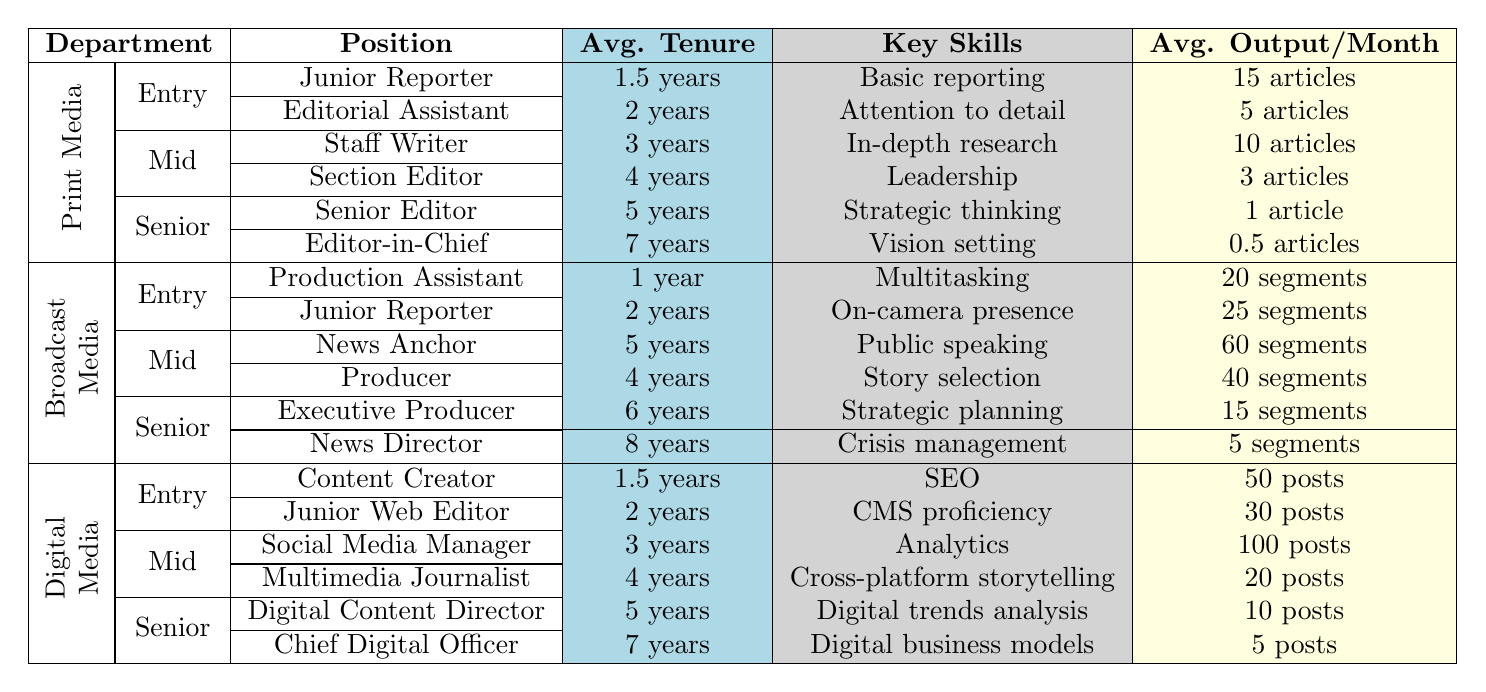What is the average tenure for a Junior Reporter in Print Media? The table shows that the average tenure for a Junior Reporter in Print Media is listed as 1.5 years.
Answer: 1.5 years Which role has the highest average output per month in Digital Media? The role of Social Media Manager has the highest average output per month with 100 posts, as compared to other roles in Digital Media.
Answer: Social Media Manager What is the typical assignment for a Senior Editor in Print Media? The typical assignment for a Senior Editor in Print Media is "Overall content strategy, mentoring," as indicated in the table under the Senior Level section for Print Media.
Answer: Overall content strategy, mentoring How many segments per month does a News Director produce compared to a Producer? A News Director produces 5 segments per month while a Producer produces 40 segments. The difference is 40 - 5 = 35 segments.
Answer: The difference is 35 segments In which department and at what level is the Digital Content Director? The Digital Content Director is in the Digital Media department at the Senior Level according to the table.
Answer: Digital Media, Senior Level What are the key skills developed by an Editorial Assistant and how do they differ from those of a Section Editor? An Editorial Assistant develops key skills such as attention to detail and time management, while a Section Editor develops leadership and editorial judgment, illustrating a difference in skill sets related to their roles.
Answer: Attention to detail, time management; Leadership, editorial judgment Is it true that the average tenure for the Chief Digital Officer is longer than that of the Senior Editor? Yes, the average tenure for the Chief Digital Officer is 7 years while the Senior Editor's tenure is 5 years, confirming the statement is true.
Answer: Yes How does the average articles published per month by an Editorial Assistant compare with that of a Staff Writer? An Editorial Assistant publishes an average of 5 articles per month, while a Staff Writer publishes 10 articles per month. The Staff Writer produces 5 more articles than the Editorial Assistant.
Answer: The difference is 5 articles What is the average tenure for the roles in the Broadcast Media department compared across all levels? The average tenures are: Entry Level: 1.5 years (average of 1 and 2 years), Mid Level: 4.5 years (average of 4 and 5 years), Senior Level: 7 years (average of 6 and 8 years). Mid Level has the lowest average tenure at 4.5 years.
Answer: Mid Level has the lowest average tenure at 4.5 years Which position in Print Media requires the least average output per month? In Print Media, the position with the least average output per month is the Editor-in-Chief, producing 0.5 articles, as seen in the table.
Answer: Editor-in-Chief What key skills differentiate a Multimedia Journalist from a Social Media Manager? A Multimedia Journalist develops skills in cross-platform storytelling and audio/video editing, while a Social Media Manager focuses on analytics and brand voice development, highlighting their different areas of expertise.
Answer: Cross-platform storytelling, audio/video editing; Analytics, brand voice development 